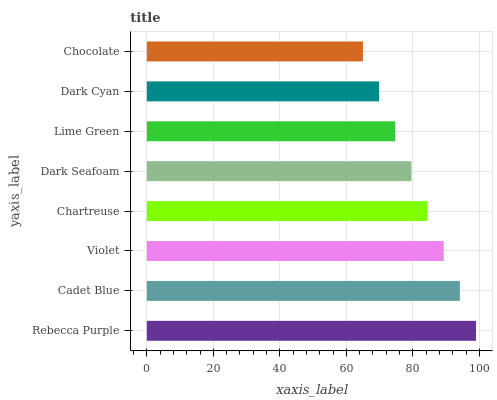Is Chocolate the minimum?
Answer yes or no. Yes. Is Rebecca Purple the maximum?
Answer yes or no. Yes. Is Cadet Blue the minimum?
Answer yes or no. No. Is Cadet Blue the maximum?
Answer yes or no. No. Is Rebecca Purple greater than Cadet Blue?
Answer yes or no. Yes. Is Cadet Blue less than Rebecca Purple?
Answer yes or no. Yes. Is Cadet Blue greater than Rebecca Purple?
Answer yes or no. No. Is Rebecca Purple less than Cadet Blue?
Answer yes or no. No. Is Chartreuse the high median?
Answer yes or no. Yes. Is Dark Seafoam the low median?
Answer yes or no. Yes. Is Dark Seafoam the high median?
Answer yes or no. No. Is Violet the low median?
Answer yes or no. No. 